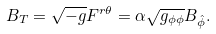<formula> <loc_0><loc_0><loc_500><loc_500>B _ { T } = \sqrt { - g } F ^ { r \theta } = \alpha \sqrt { g _ { \phi \phi } } B _ { \hat { \phi } } .</formula> 